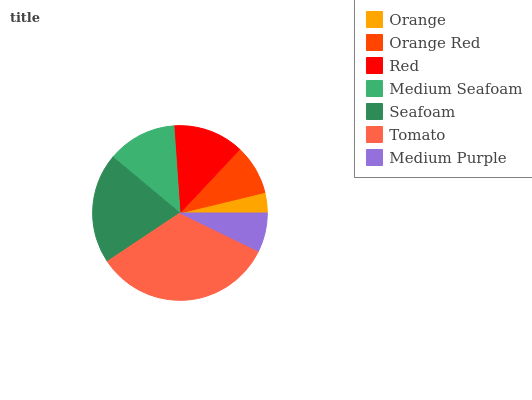Is Orange the minimum?
Answer yes or no. Yes. Is Tomato the maximum?
Answer yes or no. Yes. Is Orange Red the minimum?
Answer yes or no. No. Is Orange Red the maximum?
Answer yes or no. No. Is Orange Red greater than Orange?
Answer yes or no. Yes. Is Orange less than Orange Red?
Answer yes or no. Yes. Is Orange greater than Orange Red?
Answer yes or no. No. Is Orange Red less than Orange?
Answer yes or no. No. Is Medium Seafoam the high median?
Answer yes or no. Yes. Is Medium Seafoam the low median?
Answer yes or no. Yes. Is Medium Purple the high median?
Answer yes or no. No. Is Orange the low median?
Answer yes or no. No. 